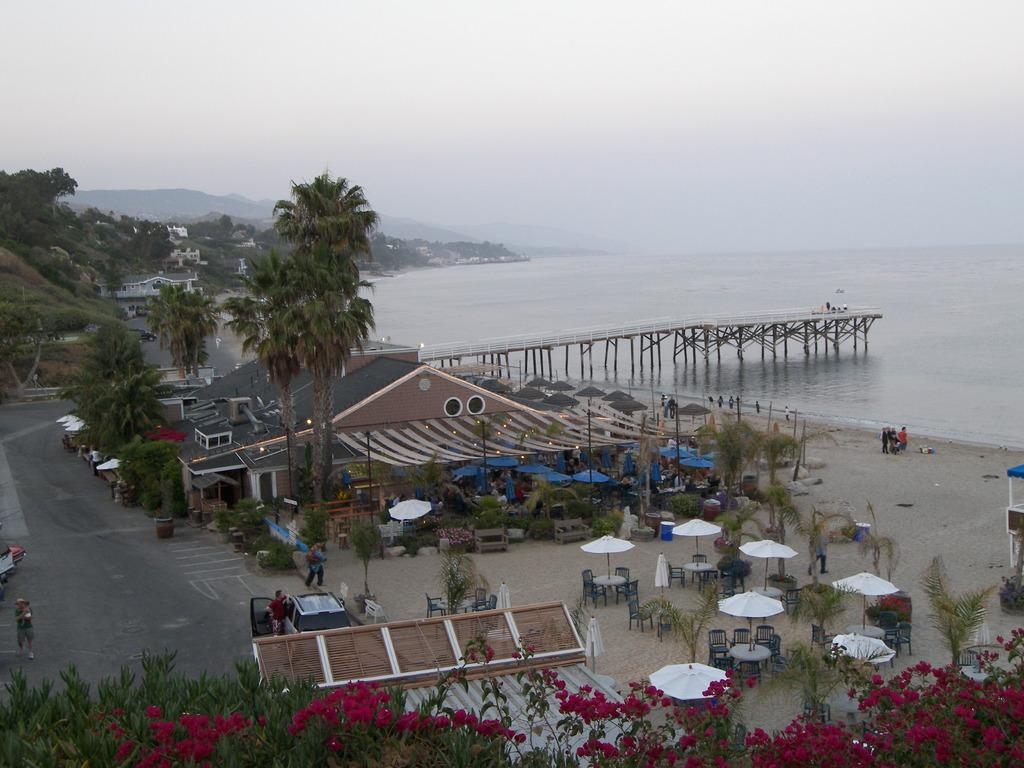What type of structures can be seen in the image? There are houses in the image. What type of vegetation is present in the image? There are trees and plants in the image. Are there any living beings in the image? Yes, there are people in the image. What type of transportation is visible in the image? There are vehicles in the image. What is the setting of the image? The image features a road. What else can be seen in the background of the image? There is water, sky, and mountains visible in the background. What type of stick is being used for destruction in the image? There is no stick or destruction present in the image. What type of pleasure can be seen being experienced by the people in the image? The image does not depict any specific pleasure being experienced by the people; it simply shows them in the setting. 